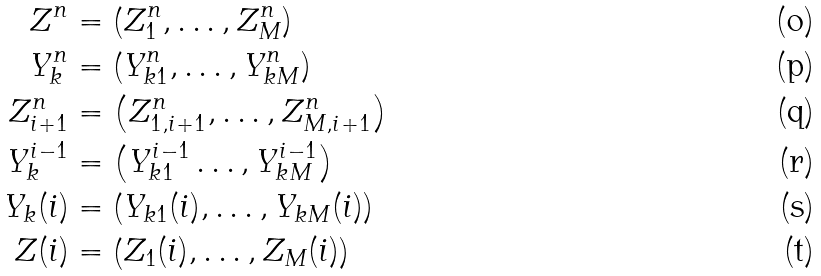<formula> <loc_0><loc_0><loc_500><loc_500>Z ^ { n } & = \left ( Z _ { 1 } ^ { n } , \dots , Z _ { M } ^ { n } \right ) \\ Y _ { k } ^ { n } & = \left ( Y _ { k 1 } ^ { n } , \dots , Y _ { k M } ^ { n } \right ) \\ Z _ { i + 1 } ^ { n } & = \left ( Z _ { 1 , i + 1 } ^ { n } , \dots , Z _ { M , i + 1 } ^ { n } \right ) \\ Y _ { k } ^ { i - 1 } & = \left ( Y _ { k 1 } ^ { i - 1 } \dots , Y _ { k M } ^ { i - 1 } \right ) \\ Y _ { k } ( i ) & = \left ( Y _ { k 1 } ( i ) , \dots , Y _ { k M } ( i ) \right ) \\ Z ( i ) & = \left ( Z _ { 1 } ( i ) , \dots , Z _ { M } ( i ) \right )</formula> 